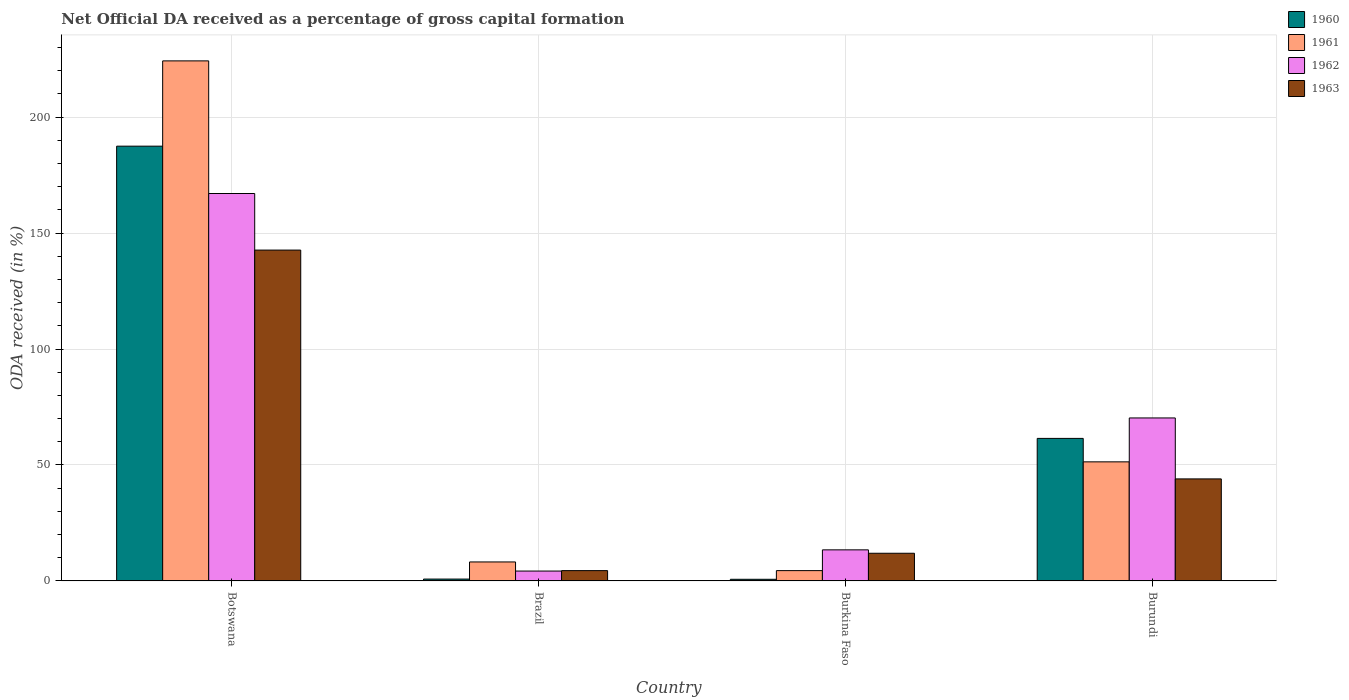How many groups of bars are there?
Your answer should be compact. 4. Are the number of bars per tick equal to the number of legend labels?
Make the answer very short. Yes. Are the number of bars on each tick of the X-axis equal?
Your answer should be compact. Yes. What is the label of the 3rd group of bars from the left?
Make the answer very short. Burkina Faso. What is the net ODA received in 1962 in Burkina Faso?
Provide a short and direct response. 13.4. Across all countries, what is the maximum net ODA received in 1962?
Your response must be concise. 167.07. Across all countries, what is the minimum net ODA received in 1962?
Give a very brief answer. 4.26. In which country was the net ODA received in 1962 maximum?
Give a very brief answer. Botswana. In which country was the net ODA received in 1963 minimum?
Your answer should be very brief. Brazil. What is the total net ODA received in 1961 in the graph?
Provide a succinct answer. 288.27. What is the difference between the net ODA received in 1962 in Burkina Faso and that in Burundi?
Your answer should be very brief. -56.88. What is the difference between the net ODA received in 1962 in Botswana and the net ODA received in 1960 in Burundi?
Offer a very short reply. 105.6. What is the average net ODA received in 1962 per country?
Give a very brief answer. 63.76. What is the difference between the net ODA received of/in 1963 and net ODA received of/in 1962 in Burkina Faso?
Offer a terse response. -1.47. In how many countries, is the net ODA received in 1961 greater than 200 %?
Your answer should be compact. 1. What is the ratio of the net ODA received in 1960 in Brazil to that in Burundi?
Your answer should be very brief. 0.01. Is the difference between the net ODA received in 1963 in Botswana and Burkina Faso greater than the difference between the net ODA received in 1962 in Botswana and Burkina Faso?
Your answer should be compact. No. What is the difference between the highest and the second highest net ODA received in 1960?
Ensure brevity in your answer.  -186.68. What is the difference between the highest and the lowest net ODA received in 1961?
Your answer should be very brief. 219.81. In how many countries, is the net ODA received in 1962 greater than the average net ODA received in 1962 taken over all countries?
Your answer should be very brief. 2. Is the sum of the net ODA received in 1960 in Brazil and Burundi greater than the maximum net ODA received in 1963 across all countries?
Give a very brief answer. No. Is it the case that in every country, the sum of the net ODA received in 1963 and net ODA received in 1960 is greater than the sum of net ODA received in 1962 and net ODA received in 1961?
Offer a very short reply. No. What does the 2nd bar from the right in Botswana represents?
Make the answer very short. 1962. What is the difference between two consecutive major ticks on the Y-axis?
Your answer should be compact. 50. Are the values on the major ticks of Y-axis written in scientific E-notation?
Ensure brevity in your answer.  No. Does the graph contain any zero values?
Your response must be concise. No. Does the graph contain grids?
Provide a short and direct response. Yes. Where does the legend appear in the graph?
Offer a very short reply. Top right. How many legend labels are there?
Offer a very short reply. 4. What is the title of the graph?
Your answer should be very brief. Net Official DA received as a percentage of gross capital formation. What is the label or title of the Y-axis?
Provide a short and direct response. ODA received (in %). What is the ODA received (in %) in 1960 in Botswana?
Your answer should be compact. 187.49. What is the ODA received (in %) in 1961 in Botswana?
Your answer should be very brief. 224.27. What is the ODA received (in %) in 1962 in Botswana?
Make the answer very short. 167.07. What is the ODA received (in %) in 1963 in Botswana?
Provide a short and direct response. 142.68. What is the ODA received (in %) of 1960 in Brazil?
Keep it short and to the point. 0.81. What is the ODA received (in %) of 1961 in Brazil?
Your response must be concise. 8.19. What is the ODA received (in %) of 1962 in Brazil?
Provide a short and direct response. 4.26. What is the ODA received (in %) of 1963 in Brazil?
Your response must be concise. 4.45. What is the ODA received (in %) of 1960 in Burkina Faso?
Ensure brevity in your answer.  0.71. What is the ODA received (in %) in 1961 in Burkina Faso?
Give a very brief answer. 4.45. What is the ODA received (in %) of 1962 in Burkina Faso?
Give a very brief answer. 13.4. What is the ODA received (in %) of 1963 in Burkina Faso?
Your answer should be very brief. 11.94. What is the ODA received (in %) of 1960 in Burundi?
Your response must be concise. 61.47. What is the ODA received (in %) in 1961 in Burundi?
Offer a very short reply. 51.36. What is the ODA received (in %) of 1962 in Burundi?
Your response must be concise. 70.29. Across all countries, what is the maximum ODA received (in %) of 1960?
Your answer should be very brief. 187.49. Across all countries, what is the maximum ODA received (in %) of 1961?
Provide a short and direct response. 224.27. Across all countries, what is the maximum ODA received (in %) of 1962?
Offer a very short reply. 167.07. Across all countries, what is the maximum ODA received (in %) in 1963?
Your answer should be compact. 142.68. Across all countries, what is the minimum ODA received (in %) in 1960?
Ensure brevity in your answer.  0.71. Across all countries, what is the minimum ODA received (in %) in 1961?
Offer a terse response. 4.45. Across all countries, what is the minimum ODA received (in %) in 1962?
Provide a short and direct response. 4.26. Across all countries, what is the minimum ODA received (in %) of 1963?
Make the answer very short. 4.45. What is the total ODA received (in %) of 1960 in the graph?
Provide a short and direct response. 250.47. What is the total ODA received (in %) in 1961 in the graph?
Keep it short and to the point. 288.27. What is the total ODA received (in %) of 1962 in the graph?
Give a very brief answer. 255.02. What is the total ODA received (in %) in 1963 in the graph?
Make the answer very short. 203.06. What is the difference between the ODA received (in %) of 1960 in Botswana and that in Brazil?
Give a very brief answer. 186.68. What is the difference between the ODA received (in %) of 1961 in Botswana and that in Brazil?
Make the answer very short. 216.07. What is the difference between the ODA received (in %) of 1962 in Botswana and that in Brazil?
Your answer should be compact. 162.81. What is the difference between the ODA received (in %) of 1963 in Botswana and that in Brazil?
Offer a terse response. 138.23. What is the difference between the ODA received (in %) in 1960 in Botswana and that in Burkina Faso?
Provide a short and direct response. 186.78. What is the difference between the ODA received (in %) in 1961 in Botswana and that in Burkina Faso?
Your response must be concise. 219.81. What is the difference between the ODA received (in %) of 1962 in Botswana and that in Burkina Faso?
Ensure brevity in your answer.  153.67. What is the difference between the ODA received (in %) of 1963 in Botswana and that in Burkina Faso?
Keep it short and to the point. 130.74. What is the difference between the ODA received (in %) in 1960 in Botswana and that in Burundi?
Offer a terse response. 126.02. What is the difference between the ODA received (in %) of 1961 in Botswana and that in Burundi?
Give a very brief answer. 172.91. What is the difference between the ODA received (in %) in 1962 in Botswana and that in Burundi?
Offer a terse response. 96.78. What is the difference between the ODA received (in %) in 1963 in Botswana and that in Burundi?
Keep it short and to the point. 98.68. What is the difference between the ODA received (in %) of 1960 in Brazil and that in Burkina Faso?
Your answer should be very brief. 0.1. What is the difference between the ODA received (in %) of 1961 in Brazil and that in Burkina Faso?
Provide a succinct answer. 3.74. What is the difference between the ODA received (in %) in 1962 in Brazil and that in Burkina Faso?
Your answer should be compact. -9.14. What is the difference between the ODA received (in %) of 1963 in Brazil and that in Burkina Faso?
Make the answer very short. -7.49. What is the difference between the ODA received (in %) in 1960 in Brazil and that in Burundi?
Your answer should be very brief. -60.66. What is the difference between the ODA received (in %) of 1961 in Brazil and that in Burundi?
Provide a short and direct response. -43.17. What is the difference between the ODA received (in %) of 1962 in Brazil and that in Burundi?
Provide a succinct answer. -66.02. What is the difference between the ODA received (in %) of 1963 in Brazil and that in Burundi?
Your response must be concise. -39.55. What is the difference between the ODA received (in %) of 1960 in Burkina Faso and that in Burundi?
Your answer should be very brief. -60.76. What is the difference between the ODA received (in %) of 1961 in Burkina Faso and that in Burundi?
Ensure brevity in your answer.  -46.9. What is the difference between the ODA received (in %) of 1962 in Burkina Faso and that in Burundi?
Offer a terse response. -56.88. What is the difference between the ODA received (in %) of 1963 in Burkina Faso and that in Burundi?
Your answer should be very brief. -32.06. What is the difference between the ODA received (in %) of 1960 in Botswana and the ODA received (in %) of 1961 in Brazil?
Your response must be concise. 179.29. What is the difference between the ODA received (in %) in 1960 in Botswana and the ODA received (in %) in 1962 in Brazil?
Keep it short and to the point. 183.22. What is the difference between the ODA received (in %) in 1960 in Botswana and the ODA received (in %) in 1963 in Brazil?
Ensure brevity in your answer.  183.04. What is the difference between the ODA received (in %) of 1961 in Botswana and the ODA received (in %) of 1962 in Brazil?
Provide a succinct answer. 220. What is the difference between the ODA received (in %) in 1961 in Botswana and the ODA received (in %) in 1963 in Brazil?
Keep it short and to the point. 219.82. What is the difference between the ODA received (in %) of 1962 in Botswana and the ODA received (in %) of 1963 in Brazil?
Your response must be concise. 162.62. What is the difference between the ODA received (in %) of 1960 in Botswana and the ODA received (in %) of 1961 in Burkina Faso?
Your answer should be very brief. 183.03. What is the difference between the ODA received (in %) of 1960 in Botswana and the ODA received (in %) of 1962 in Burkina Faso?
Provide a succinct answer. 174.08. What is the difference between the ODA received (in %) of 1960 in Botswana and the ODA received (in %) of 1963 in Burkina Faso?
Your answer should be very brief. 175.55. What is the difference between the ODA received (in %) of 1961 in Botswana and the ODA received (in %) of 1962 in Burkina Faso?
Your answer should be compact. 210.86. What is the difference between the ODA received (in %) in 1961 in Botswana and the ODA received (in %) in 1963 in Burkina Faso?
Your answer should be very brief. 212.33. What is the difference between the ODA received (in %) of 1962 in Botswana and the ODA received (in %) of 1963 in Burkina Faso?
Your response must be concise. 155.13. What is the difference between the ODA received (in %) of 1960 in Botswana and the ODA received (in %) of 1961 in Burundi?
Give a very brief answer. 136.13. What is the difference between the ODA received (in %) in 1960 in Botswana and the ODA received (in %) in 1962 in Burundi?
Ensure brevity in your answer.  117.2. What is the difference between the ODA received (in %) of 1960 in Botswana and the ODA received (in %) of 1963 in Burundi?
Provide a short and direct response. 143.49. What is the difference between the ODA received (in %) of 1961 in Botswana and the ODA received (in %) of 1962 in Burundi?
Your answer should be very brief. 153.98. What is the difference between the ODA received (in %) of 1961 in Botswana and the ODA received (in %) of 1963 in Burundi?
Offer a terse response. 180.27. What is the difference between the ODA received (in %) in 1962 in Botswana and the ODA received (in %) in 1963 in Burundi?
Your answer should be very brief. 123.07. What is the difference between the ODA received (in %) of 1960 in Brazil and the ODA received (in %) of 1961 in Burkina Faso?
Make the answer very short. -3.65. What is the difference between the ODA received (in %) in 1960 in Brazil and the ODA received (in %) in 1962 in Burkina Faso?
Provide a short and direct response. -12.6. What is the difference between the ODA received (in %) in 1960 in Brazil and the ODA received (in %) in 1963 in Burkina Faso?
Offer a very short reply. -11.13. What is the difference between the ODA received (in %) in 1961 in Brazil and the ODA received (in %) in 1962 in Burkina Faso?
Your response must be concise. -5.21. What is the difference between the ODA received (in %) of 1961 in Brazil and the ODA received (in %) of 1963 in Burkina Faso?
Offer a very short reply. -3.75. What is the difference between the ODA received (in %) in 1962 in Brazil and the ODA received (in %) in 1963 in Burkina Faso?
Provide a succinct answer. -7.67. What is the difference between the ODA received (in %) of 1960 in Brazil and the ODA received (in %) of 1961 in Burundi?
Ensure brevity in your answer.  -50.55. What is the difference between the ODA received (in %) of 1960 in Brazil and the ODA received (in %) of 1962 in Burundi?
Keep it short and to the point. -69.48. What is the difference between the ODA received (in %) of 1960 in Brazil and the ODA received (in %) of 1963 in Burundi?
Keep it short and to the point. -43.19. What is the difference between the ODA received (in %) of 1961 in Brazil and the ODA received (in %) of 1962 in Burundi?
Make the answer very short. -62.09. What is the difference between the ODA received (in %) of 1961 in Brazil and the ODA received (in %) of 1963 in Burundi?
Provide a succinct answer. -35.81. What is the difference between the ODA received (in %) of 1962 in Brazil and the ODA received (in %) of 1963 in Burundi?
Your answer should be very brief. -39.74. What is the difference between the ODA received (in %) of 1960 in Burkina Faso and the ODA received (in %) of 1961 in Burundi?
Make the answer very short. -50.65. What is the difference between the ODA received (in %) in 1960 in Burkina Faso and the ODA received (in %) in 1962 in Burundi?
Your response must be concise. -69.58. What is the difference between the ODA received (in %) of 1960 in Burkina Faso and the ODA received (in %) of 1963 in Burundi?
Offer a terse response. -43.29. What is the difference between the ODA received (in %) in 1961 in Burkina Faso and the ODA received (in %) in 1962 in Burundi?
Provide a succinct answer. -65.83. What is the difference between the ODA received (in %) in 1961 in Burkina Faso and the ODA received (in %) in 1963 in Burundi?
Your response must be concise. -39.55. What is the difference between the ODA received (in %) in 1962 in Burkina Faso and the ODA received (in %) in 1963 in Burundi?
Make the answer very short. -30.6. What is the average ODA received (in %) in 1960 per country?
Your answer should be very brief. 62.62. What is the average ODA received (in %) of 1961 per country?
Your answer should be very brief. 72.07. What is the average ODA received (in %) of 1962 per country?
Your response must be concise. 63.76. What is the average ODA received (in %) in 1963 per country?
Make the answer very short. 50.77. What is the difference between the ODA received (in %) in 1960 and ODA received (in %) in 1961 in Botswana?
Give a very brief answer. -36.78. What is the difference between the ODA received (in %) in 1960 and ODA received (in %) in 1962 in Botswana?
Your answer should be compact. 20.42. What is the difference between the ODA received (in %) in 1960 and ODA received (in %) in 1963 in Botswana?
Make the answer very short. 44.81. What is the difference between the ODA received (in %) in 1961 and ODA received (in %) in 1962 in Botswana?
Ensure brevity in your answer.  57.2. What is the difference between the ODA received (in %) in 1961 and ODA received (in %) in 1963 in Botswana?
Your answer should be very brief. 81.59. What is the difference between the ODA received (in %) in 1962 and ODA received (in %) in 1963 in Botswana?
Your response must be concise. 24.39. What is the difference between the ODA received (in %) of 1960 and ODA received (in %) of 1961 in Brazil?
Ensure brevity in your answer.  -7.38. What is the difference between the ODA received (in %) in 1960 and ODA received (in %) in 1962 in Brazil?
Provide a succinct answer. -3.46. What is the difference between the ODA received (in %) of 1960 and ODA received (in %) of 1963 in Brazil?
Offer a terse response. -3.64. What is the difference between the ODA received (in %) in 1961 and ODA received (in %) in 1962 in Brazil?
Keep it short and to the point. 3.93. What is the difference between the ODA received (in %) in 1961 and ODA received (in %) in 1963 in Brazil?
Offer a terse response. 3.74. What is the difference between the ODA received (in %) in 1962 and ODA received (in %) in 1963 in Brazil?
Your answer should be compact. -0.18. What is the difference between the ODA received (in %) in 1960 and ODA received (in %) in 1961 in Burkina Faso?
Offer a terse response. -3.74. What is the difference between the ODA received (in %) in 1960 and ODA received (in %) in 1962 in Burkina Faso?
Your answer should be very brief. -12.69. What is the difference between the ODA received (in %) in 1960 and ODA received (in %) in 1963 in Burkina Faso?
Your answer should be compact. -11.23. What is the difference between the ODA received (in %) of 1961 and ODA received (in %) of 1962 in Burkina Faso?
Your response must be concise. -8.95. What is the difference between the ODA received (in %) of 1961 and ODA received (in %) of 1963 in Burkina Faso?
Provide a succinct answer. -7.48. What is the difference between the ODA received (in %) in 1962 and ODA received (in %) in 1963 in Burkina Faso?
Your answer should be compact. 1.47. What is the difference between the ODA received (in %) of 1960 and ODA received (in %) of 1961 in Burundi?
Your answer should be compact. 10.11. What is the difference between the ODA received (in %) of 1960 and ODA received (in %) of 1962 in Burundi?
Keep it short and to the point. -8.82. What is the difference between the ODA received (in %) in 1960 and ODA received (in %) in 1963 in Burundi?
Your response must be concise. 17.47. What is the difference between the ODA received (in %) in 1961 and ODA received (in %) in 1962 in Burundi?
Ensure brevity in your answer.  -18.93. What is the difference between the ODA received (in %) of 1961 and ODA received (in %) of 1963 in Burundi?
Your response must be concise. 7.36. What is the difference between the ODA received (in %) in 1962 and ODA received (in %) in 1963 in Burundi?
Give a very brief answer. 26.29. What is the ratio of the ODA received (in %) in 1960 in Botswana to that in Brazil?
Provide a short and direct response. 232.07. What is the ratio of the ODA received (in %) of 1961 in Botswana to that in Brazil?
Your answer should be compact. 27.38. What is the ratio of the ODA received (in %) of 1962 in Botswana to that in Brazil?
Your answer should be compact. 39.18. What is the ratio of the ODA received (in %) in 1963 in Botswana to that in Brazil?
Make the answer very short. 32.07. What is the ratio of the ODA received (in %) of 1960 in Botswana to that in Burkina Faso?
Your answer should be very brief. 263.92. What is the ratio of the ODA received (in %) in 1961 in Botswana to that in Burkina Faso?
Ensure brevity in your answer.  50.35. What is the ratio of the ODA received (in %) of 1962 in Botswana to that in Burkina Faso?
Your response must be concise. 12.46. What is the ratio of the ODA received (in %) in 1963 in Botswana to that in Burkina Faso?
Offer a terse response. 11.95. What is the ratio of the ODA received (in %) of 1960 in Botswana to that in Burundi?
Provide a succinct answer. 3.05. What is the ratio of the ODA received (in %) in 1961 in Botswana to that in Burundi?
Provide a short and direct response. 4.37. What is the ratio of the ODA received (in %) in 1962 in Botswana to that in Burundi?
Your answer should be compact. 2.38. What is the ratio of the ODA received (in %) of 1963 in Botswana to that in Burundi?
Keep it short and to the point. 3.24. What is the ratio of the ODA received (in %) in 1960 in Brazil to that in Burkina Faso?
Your answer should be very brief. 1.14. What is the ratio of the ODA received (in %) in 1961 in Brazil to that in Burkina Faso?
Your answer should be very brief. 1.84. What is the ratio of the ODA received (in %) of 1962 in Brazil to that in Burkina Faso?
Give a very brief answer. 0.32. What is the ratio of the ODA received (in %) of 1963 in Brazil to that in Burkina Faso?
Your answer should be very brief. 0.37. What is the ratio of the ODA received (in %) in 1960 in Brazil to that in Burundi?
Make the answer very short. 0.01. What is the ratio of the ODA received (in %) of 1961 in Brazil to that in Burundi?
Provide a short and direct response. 0.16. What is the ratio of the ODA received (in %) of 1962 in Brazil to that in Burundi?
Your answer should be compact. 0.06. What is the ratio of the ODA received (in %) in 1963 in Brazil to that in Burundi?
Your answer should be compact. 0.1. What is the ratio of the ODA received (in %) in 1960 in Burkina Faso to that in Burundi?
Make the answer very short. 0.01. What is the ratio of the ODA received (in %) in 1961 in Burkina Faso to that in Burundi?
Your answer should be very brief. 0.09. What is the ratio of the ODA received (in %) in 1962 in Burkina Faso to that in Burundi?
Your answer should be compact. 0.19. What is the ratio of the ODA received (in %) in 1963 in Burkina Faso to that in Burundi?
Give a very brief answer. 0.27. What is the difference between the highest and the second highest ODA received (in %) in 1960?
Your answer should be very brief. 126.02. What is the difference between the highest and the second highest ODA received (in %) in 1961?
Offer a terse response. 172.91. What is the difference between the highest and the second highest ODA received (in %) of 1962?
Ensure brevity in your answer.  96.78. What is the difference between the highest and the second highest ODA received (in %) in 1963?
Your answer should be compact. 98.68. What is the difference between the highest and the lowest ODA received (in %) of 1960?
Ensure brevity in your answer.  186.78. What is the difference between the highest and the lowest ODA received (in %) of 1961?
Ensure brevity in your answer.  219.81. What is the difference between the highest and the lowest ODA received (in %) of 1962?
Offer a very short reply. 162.81. What is the difference between the highest and the lowest ODA received (in %) of 1963?
Ensure brevity in your answer.  138.23. 